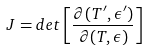Convert formula to latex. <formula><loc_0><loc_0><loc_500><loc_500>J = d e t \left [ \frac { \partial { ( T ^ { \prime } , \epsilon ^ { \prime } ) } } { \partial { ( T , \epsilon ) } } \right ]</formula> 